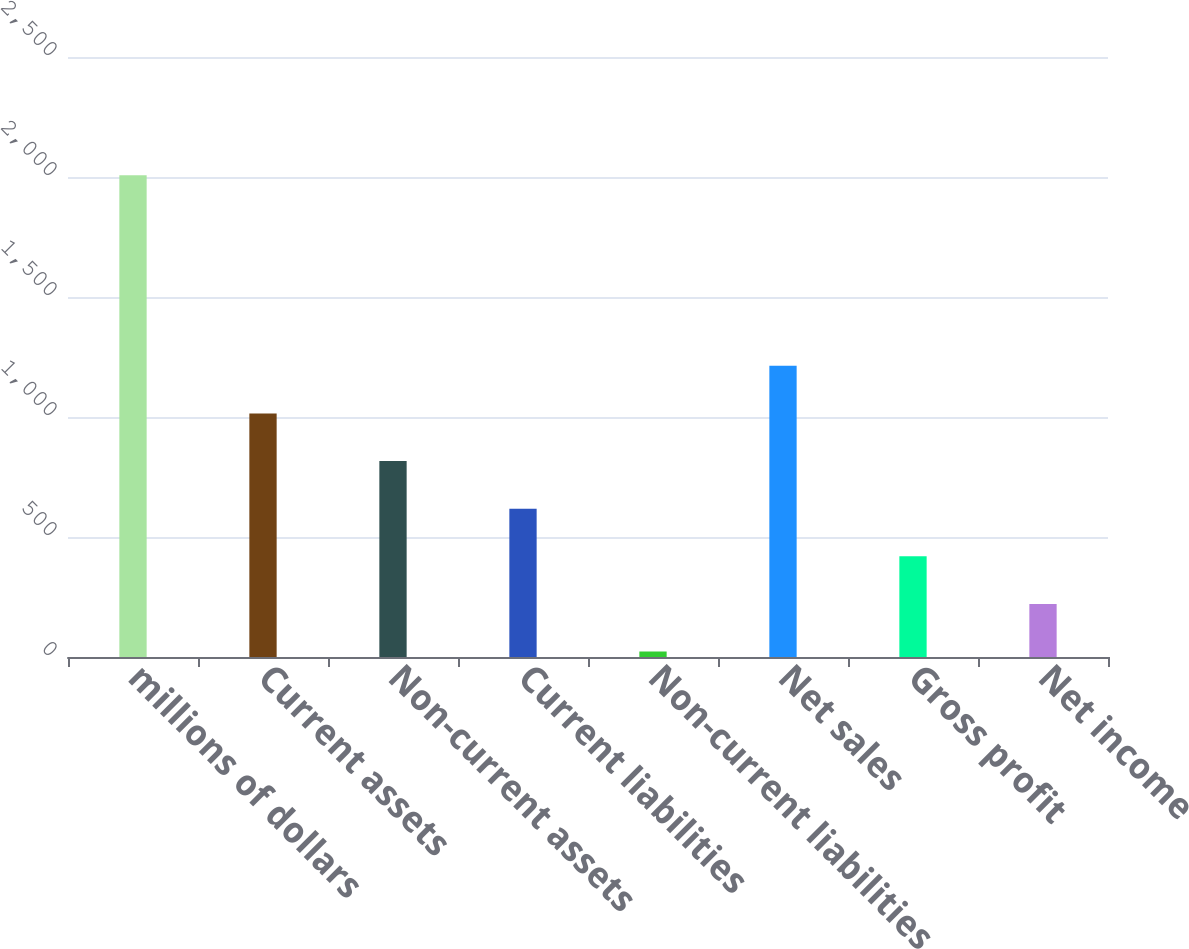<chart> <loc_0><loc_0><loc_500><loc_500><bar_chart><fcel>millions of dollars<fcel>Current assets<fcel>Non-current assets<fcel>Current liabilities<fcel>Non-current liabilities<fcel>Net sales<fcel>Gross profit<fcel>Net income<nl><fcel>2007<fcel>1014.95<fcel>816.54<fcel>618.13<fcel>22.9<fcel>1213.36<fcel>419.72<fcel>221.31<nl></chart> 